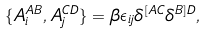<formula> <loc_0><loc_0><loc_500><loc_500>\{ A _ { i } ^ { A B } , A _ { j } ^ { C D } \} = \beta \epsilon _ { i j } \delta ^ { [ A C } \delta ^ { B ] D } ,</formula> 